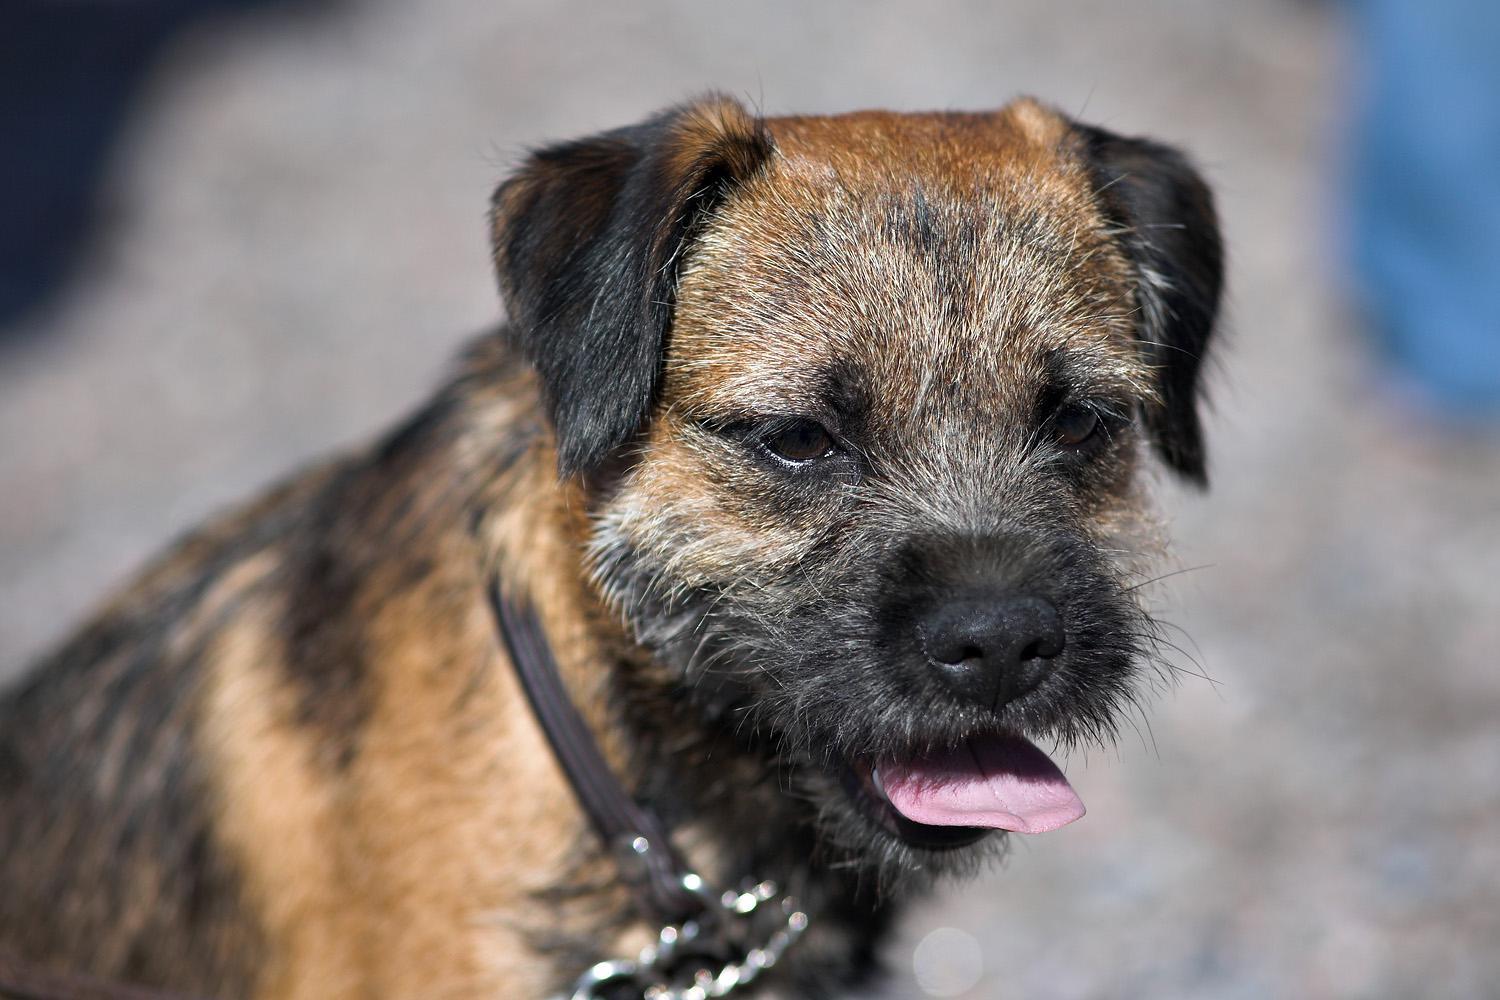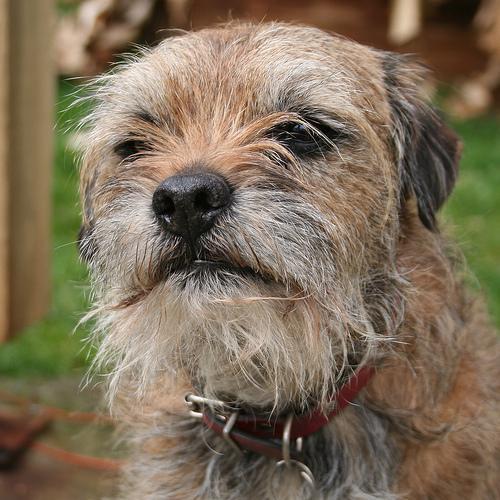The first image is the image on the left, the second image is the image on the right. Examine the images to the left and right. Is the description "There are two dogs wearing a collar." accurate? Answer yes or no. Yes. 